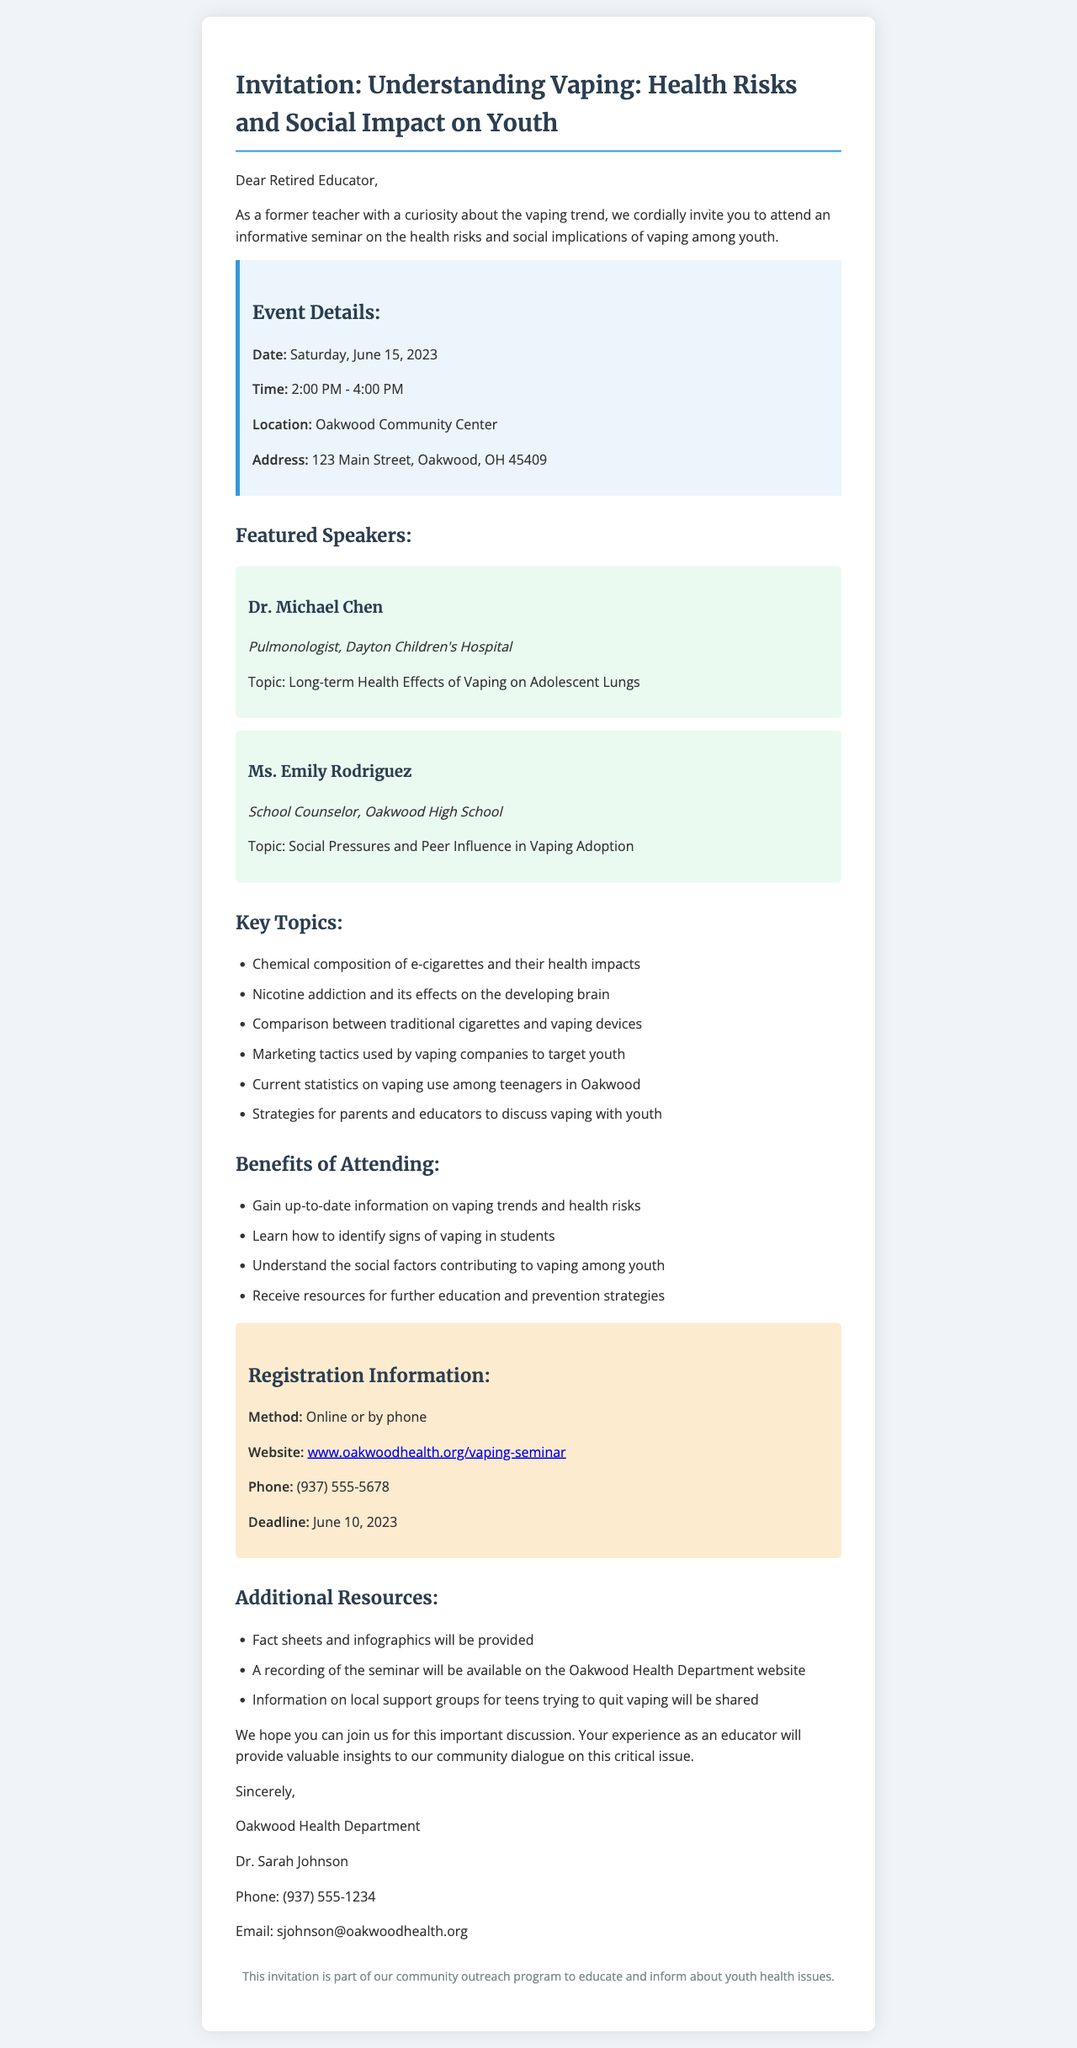What is the name of the seminar? The seminar name is explicitly stated in the event details section.
Answer: Understanding Vaping: Health Risks and Social Impact on Youth What is the date of the seminar? The date is provided in the event details section.
Answer: Saturday, June 15, 2023 Who is the contact person for the organizer? The contact person's name is mentioned under the organizer's details.
Answer: Dr. Sarah Johnson What topic will Dr. Michael Chen speak on? The specific topic for Dr. Chen is listed in the speakers' section.
Answer: Long-term Health Effects of Vaping on Adolescent Lungs How can attendees register for the seminar? The registration method is explained in the registration information section.
Answer: Online or by phone What time does the seminar start? The start time is included in the event details section.
Answer: 2:00 PM Which benefit of attending involves identifying signs of vaping in students? The specific benefit is mentioned in the attendee benefits section.
Answer: Learn how to identify signs of vaping in students How many key topics are listed in the document? By counting the number of topics listed in the key topics section.
Answer: Six What type of resources will be provided during the seminar? The type of resources is specified in the additional resources section.
Answer: Fact sheets and infographics will be provided 